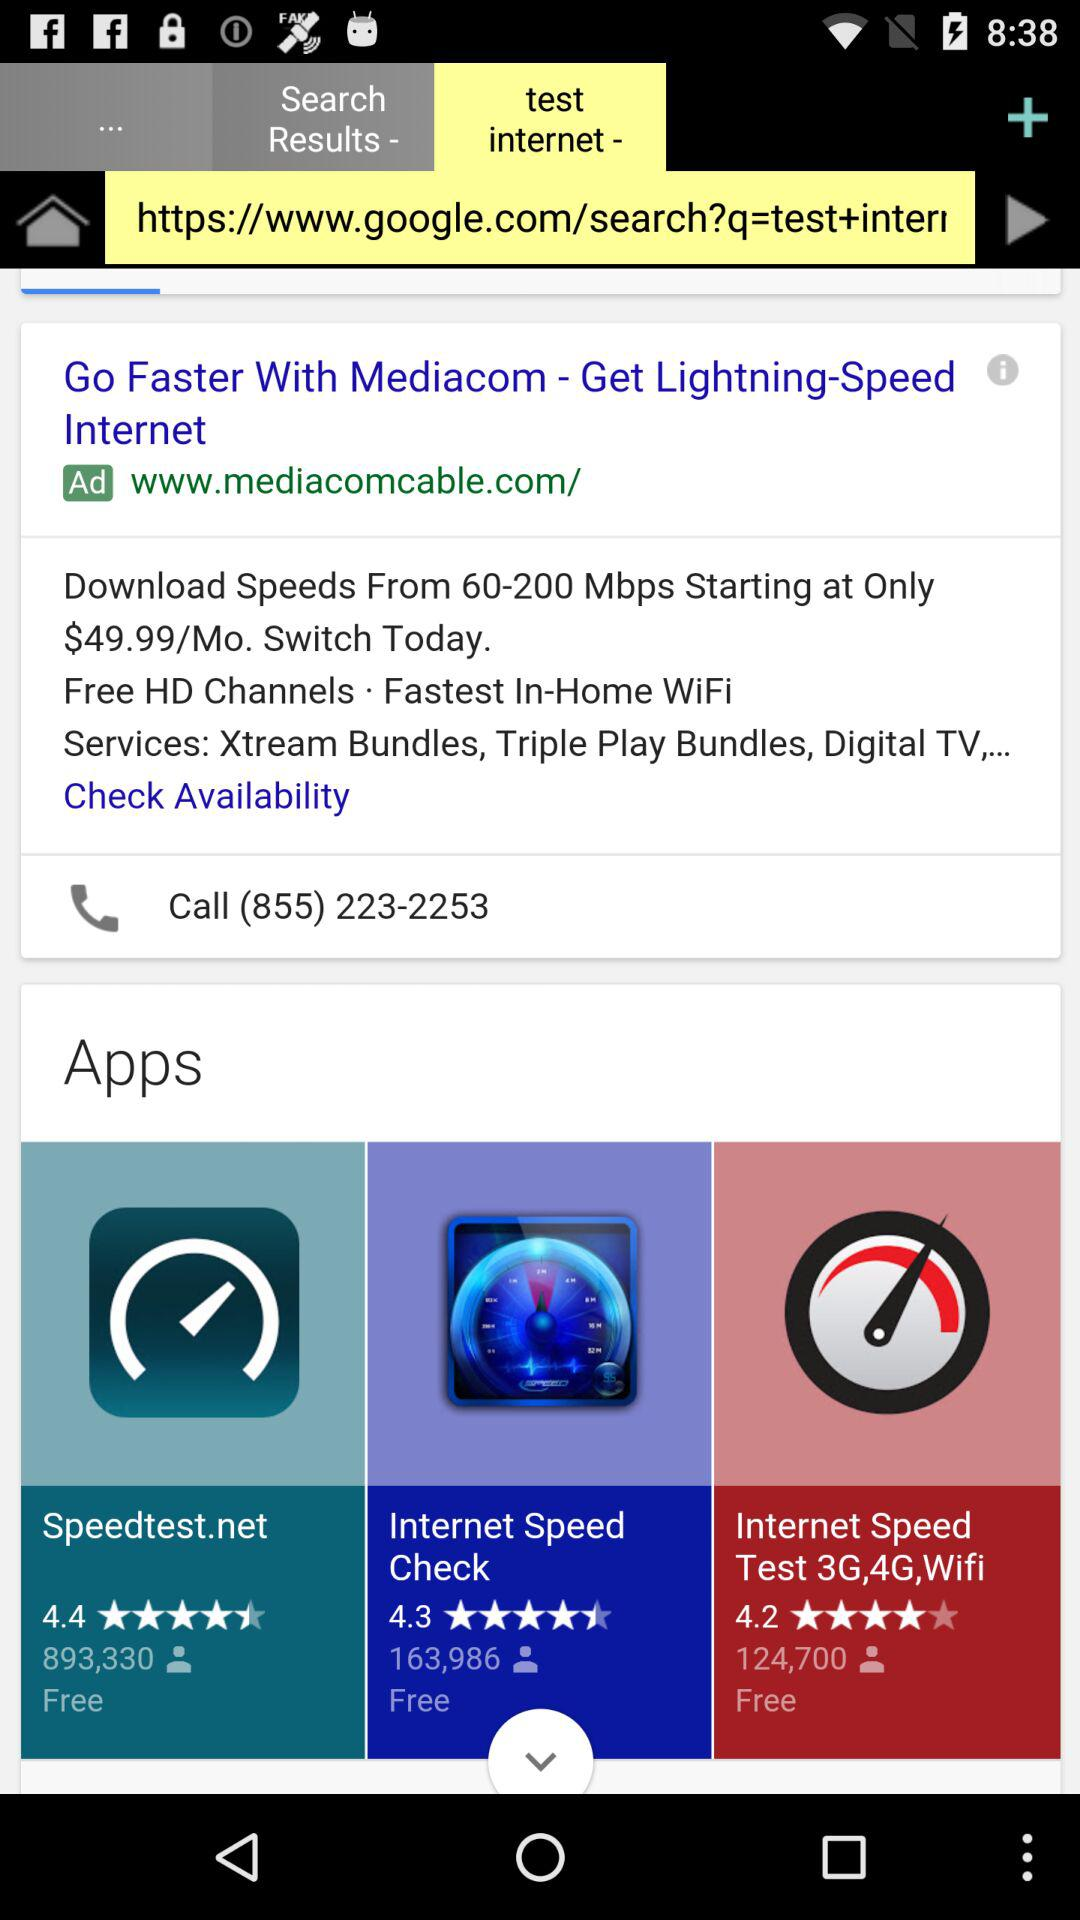What is the number of people who downloaded the "Internet Speed Check" app? The number of people who downloaded the "Internet Speed Check" app is 163,986. 